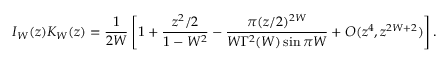<formula> <loc_0><loc_0><loc_500><loc_500>I _ { W } ( z ) K _ { W } ( z ) = \frac { 1 } { 2 W } \left [ 1 + \frac { z ^ { 2 } / 2 } { 1 - W ^ { 2 } } - \frac { \pi ( z / 2 ) ^ { 2 W } } { W \Gamma ^ { 2 } ( W ) \sin \pi W } + O ( z ^ { 4 } , z ^ { 2 W + 2 } ) \right ] .</formula> 